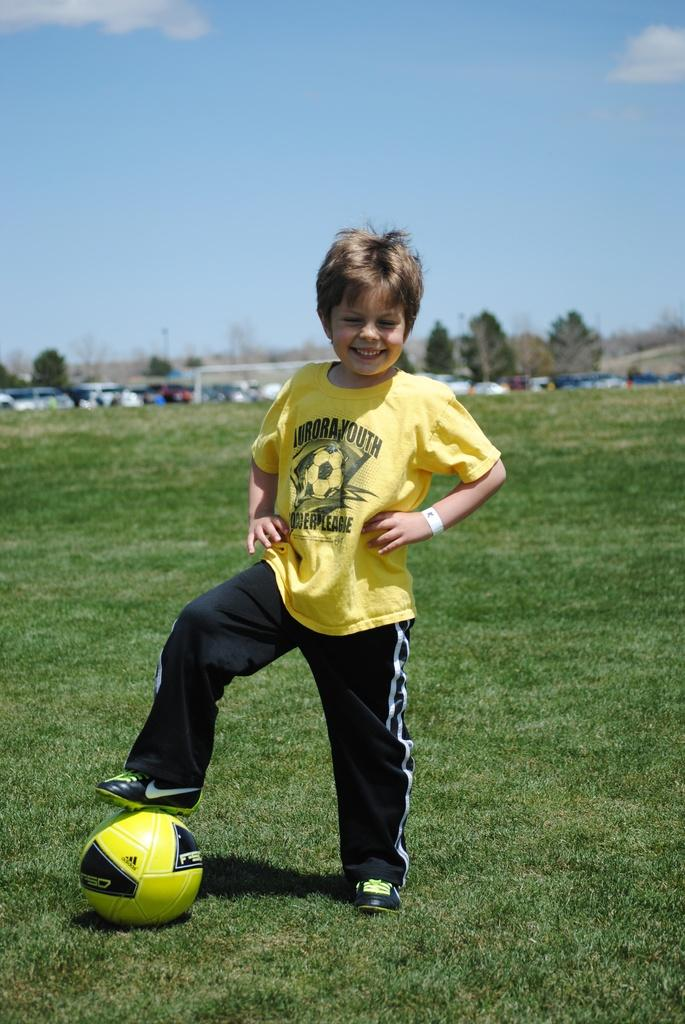<image>
Summarize the visual content of the image. A boy in an Aurora Youth shirt stands with one foot up on a soccer ball. 